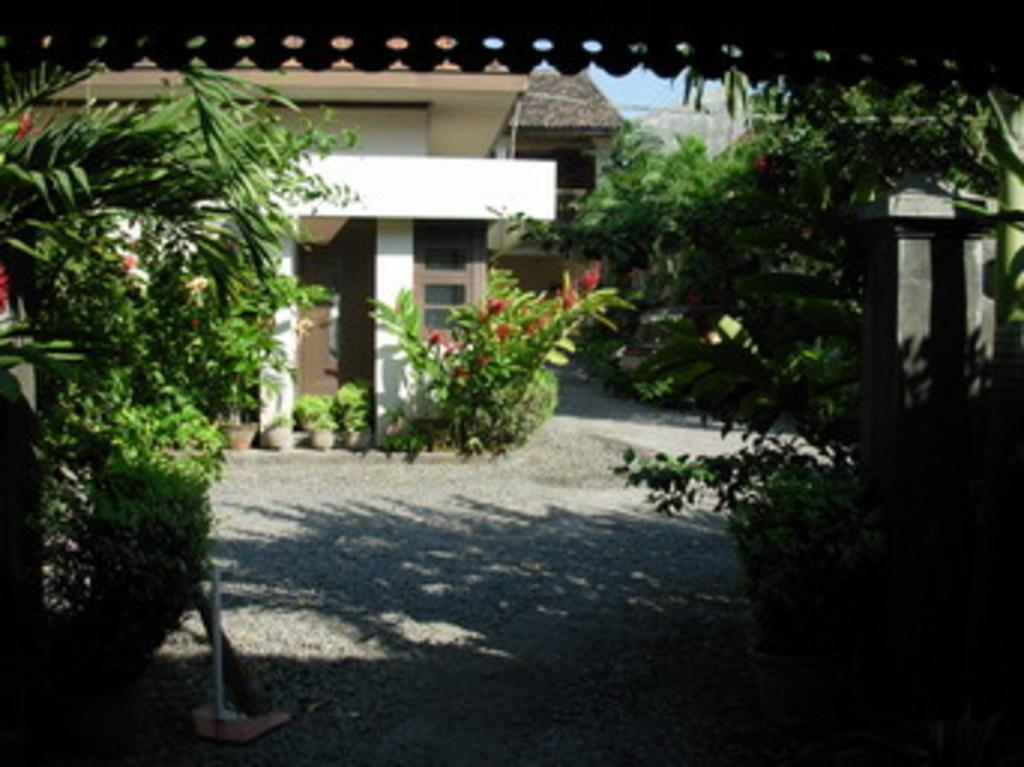What is present on both sides of the image? There are plants on both the left and right sides of the image. What can be seen on the path in the image? There are flower pots on the path in the image. What is visible in the background of the image? There is a building in the background of the image. How many blades of grass can be seen in the image? The image does not show individual blades of grass; it only shows plants and flower pots. What type of division is present between the plants on the left and right sides of the image? There is no visible division between the plants on the left and right sides of the image; they are both visible in the same area. 